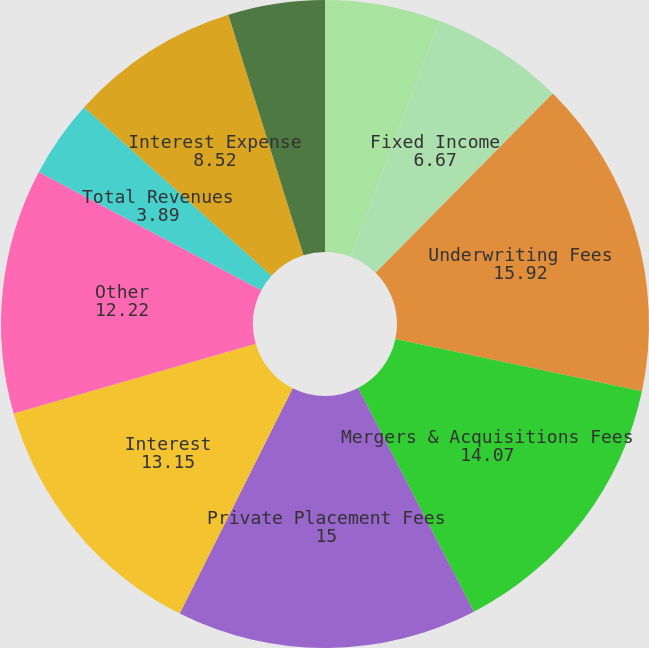<chart> <loc_0><loc_0><loc_500><loc_500><pie_chart><fcel>Equity<fcel>Fixed Income<fcel>Underwriting Fees<fcel>Mergers & Acquisitions Fees<fcel>Private Placement Fees<fcel>Interest<fcel>Other<fcel>Total Revenues<fcel>Interest Expense<fcel>Net Revenues<nl><fcel>5.74%<fcel>6.67%<fcel>15.92%<fcel>14.07%<fcel>15.0%<fcel>13.15%<fcel>12.22%<fcel>3.89%<fcel>8.52%<fcel>4.82%<nl></chart> 